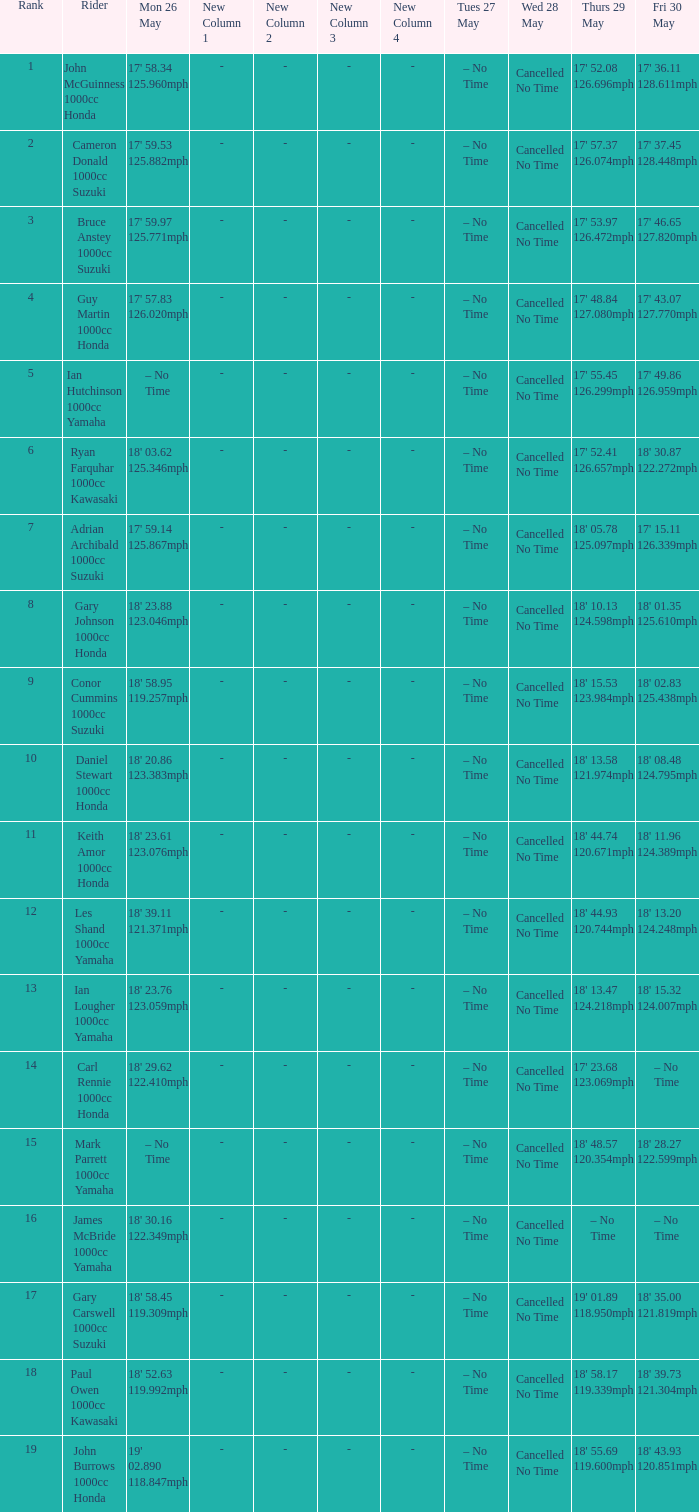What tims is wed may 28 and mon may 26 is 17' 58.34 125.960mph? Cancelled No Time. 